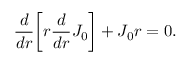<formula> <loc_0><loc_0><loc_500><loc_500>\frac { d } { d r } \left [ r \frac { d } { d r } J _ { 0 } \right ] + J _ { 0 } r = 0 .</formula> 